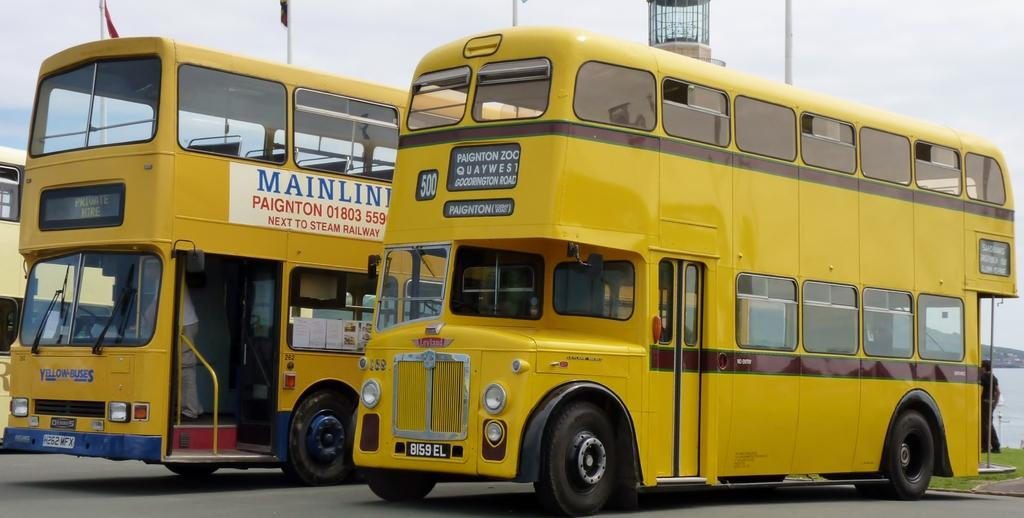What type of vehicles can be seen on the road in the image? There are Double Decker buses on the road in the image. What other objects are present in the image besides the buses? There are flags with poles in the image. What natural element is visible in the image? There is water visible in the image. What can be seen in the background of the image? There is sky visible in the background of the image. Can you describe the worm crawling on the road in the image? There is no worm present in the image; it features Double Decker buses on the road, flags with poles, water, and sky in the background. 